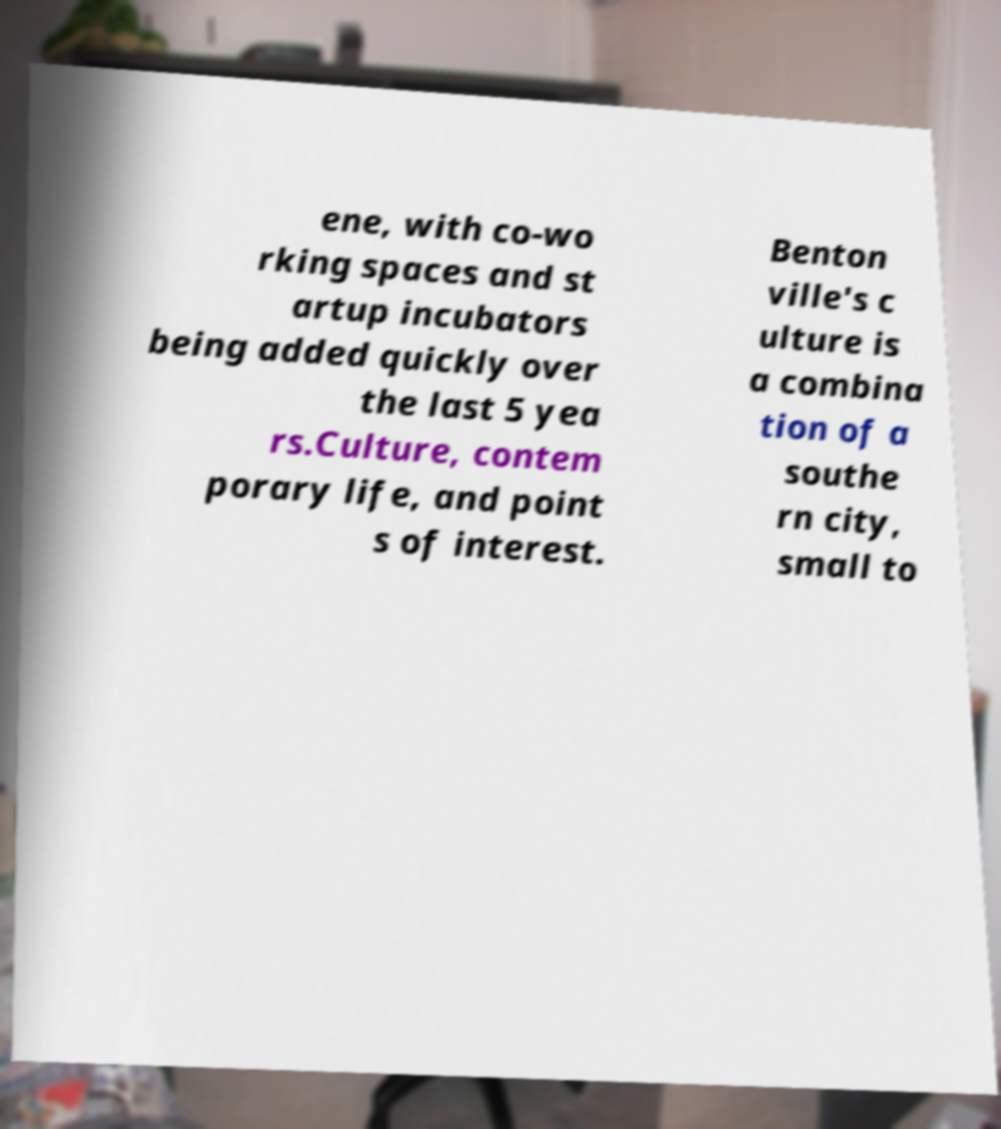What messages or text are displayed in this image? I need them in a readable, typed format. ene, with co-wo rking spaces and st artup incubators being added quickly over the last 5 yea rs.Culture, contem porary life, and point s of interest. Benton ville's c ulture is a combina tion of a southe rn city, small to 